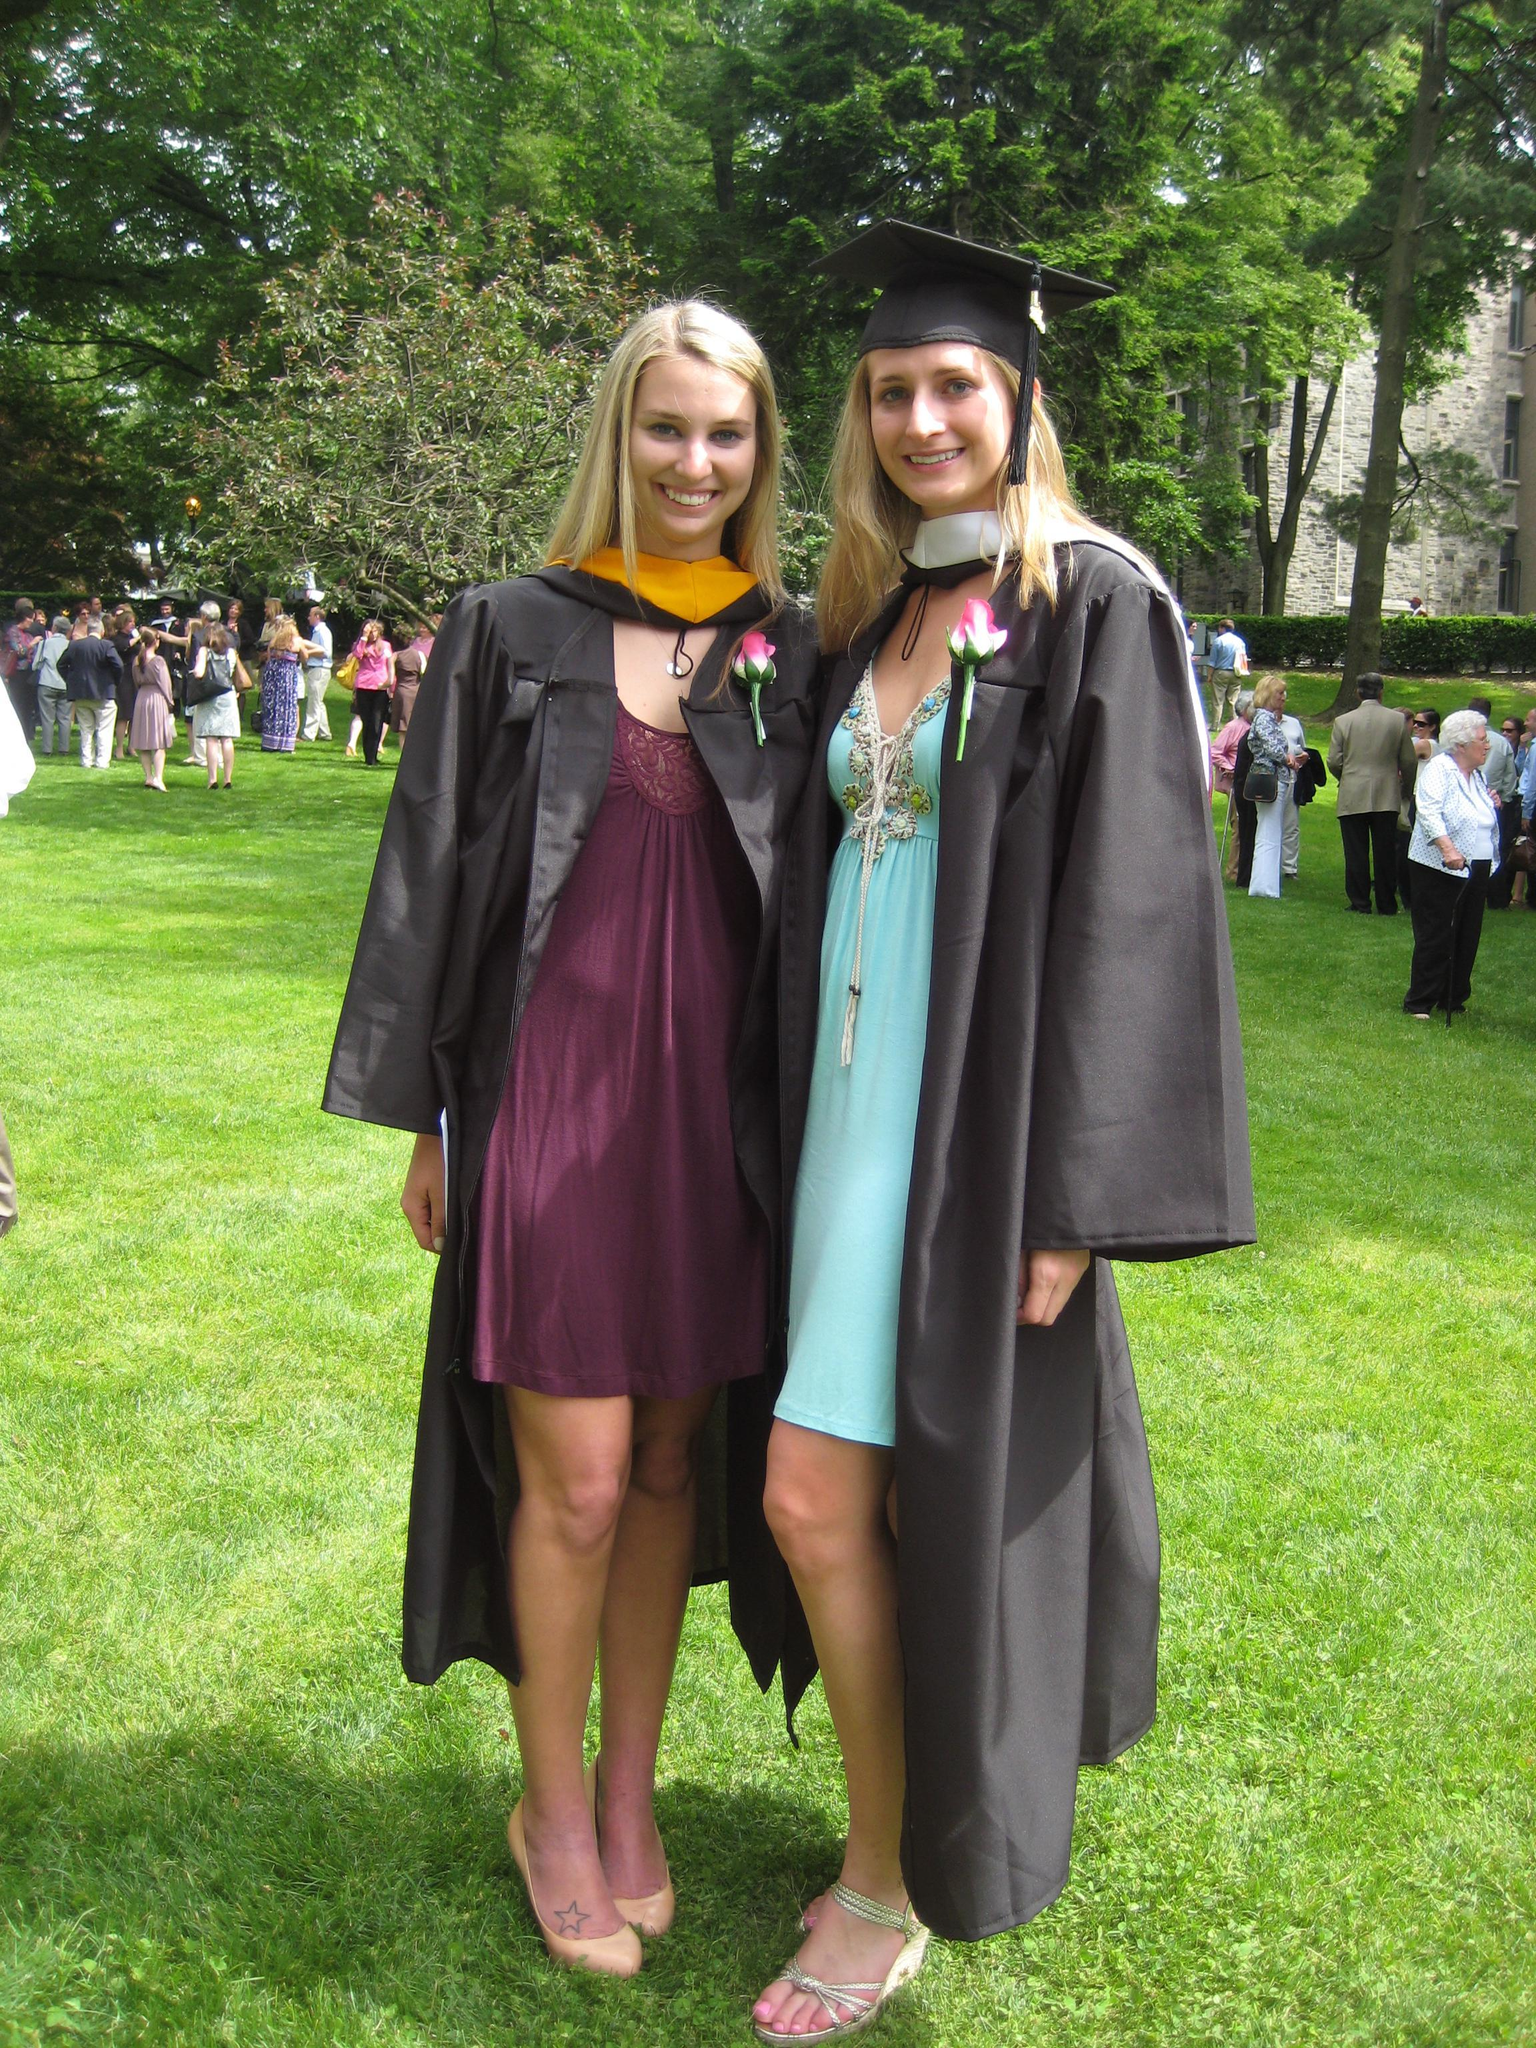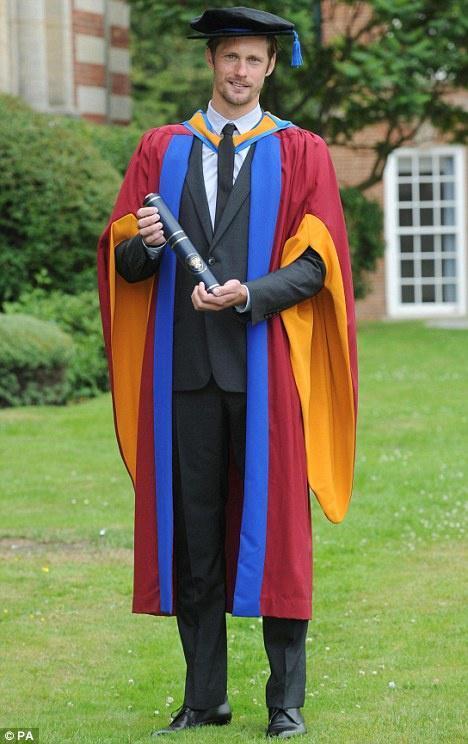The first image is the image on the left, the second image is the image on the right. Analyze the images presented: Is the assertion "There are no more than 3 graduates pictured." valid? Answer yes or no. Yes. The first image is the image on the left, the second image is the image on the right. Examine the images to the left and right. Is the description "Right image shows one male graduate posed in colorful gown on grass." accurate? Answer yes or no. Yes. 